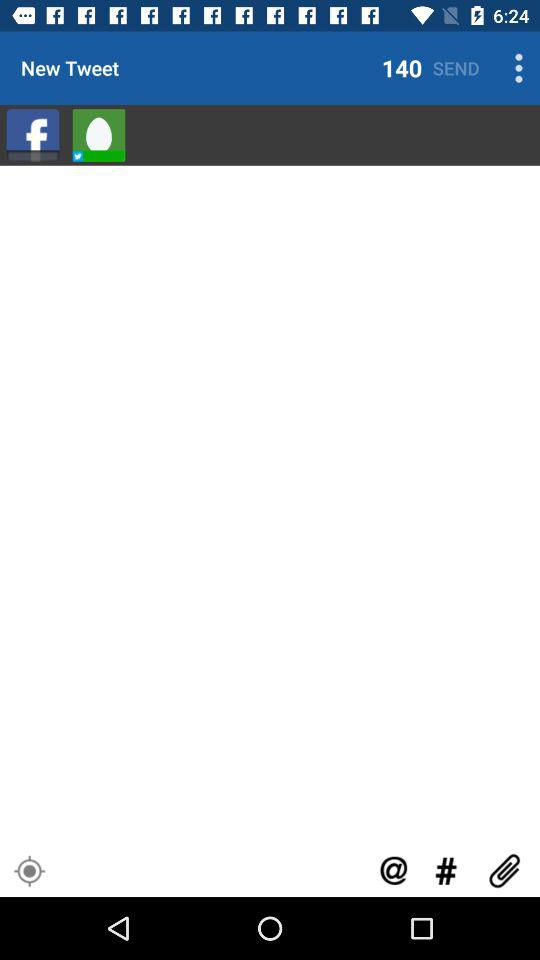How many tweets are sent?
When the provided information is insufficient, respond with <no answer>. <no answer> 